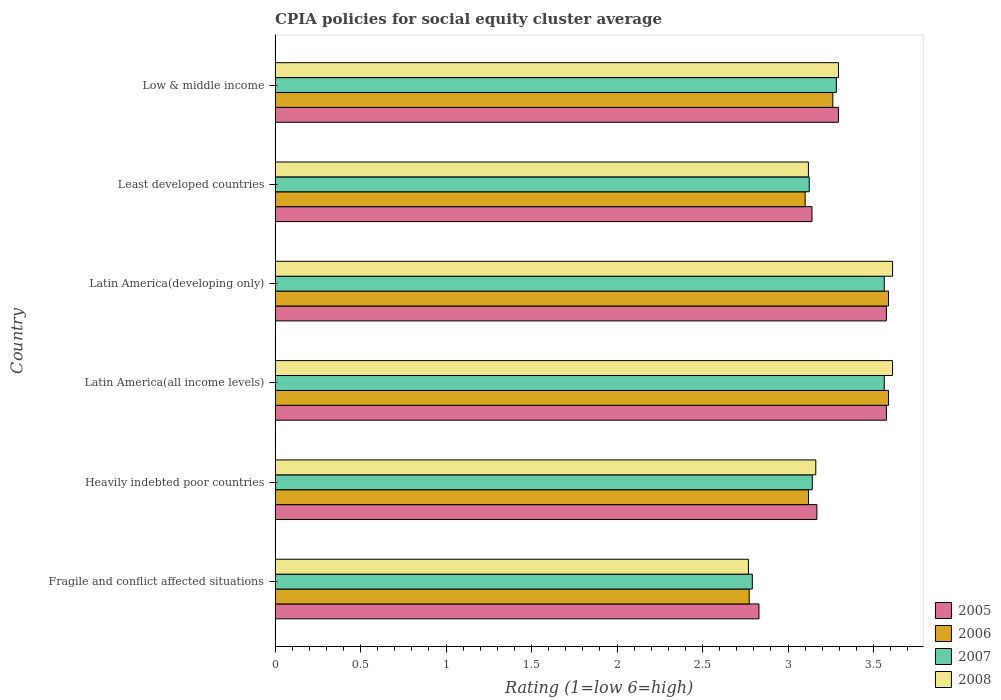How many groups of bars are there?
Your answer should be compact. 6. How many bars are there on the 4th tick from the top?
Your response must be concise. 4. How many bars are there on the 6th tick from the bottom?
Keep it short and to the point. 4. What is the label of the 4th group of bars from the top?
Provide a short and direct response. Latin America(all income levels). In how many cases, is the number of bars for a given country not equal to the number of legend labels?
Offer a terse response. 0. What is the CPIA rating in 2006 in Latin America(all income levels)?
Offer a terse response. 3.59. Across all countries, what is the maximum CPIA rating in 2008?
Provide a succinct answer. 3.61. Across all countries, what is the minimum CPIA rating in 2008?
Offer a very short reply. 2.77. In which country was the CPIA rating in 2005 maximum?
Give a very brief answer. Latin America(all income levels). In which country was the CPIA rating in 2007 minimum?
Make the answer very short. Fragile and conflict affected situations. What is the total CPIA rating in 2005 in the graph?
Provide a succinct answer. 19.58. What is the difference between the CPIA rating in 2006 in Latin America(developing only) and that in Least developed countries?
Provide a succinct answer. 0.49. What is the difference between the CPIA rating in 2007 in Latin America(developing only) and the CPIA rating in 2006 in Least developed countries?
Give a very brief answer. 0.46. What is the average CPIA rating in 2006 per country?
Your answer should be very brief. 3.24. What is the difference between the CPIA rating in 2007 and CPIA rating in 2008 in Fragile and conflict affected situations?
Provide a short and direct response. 0.02. In how many countries, is the CPIA rating in 2007 greater than 3.3 ?
Offer a very short reply. 2. What is the ratio of the CPIA rating in 2006 in Latin America(developing only) to that in Low & middle income?
Keep it short and to the point. 1.1. Is the difference between the CPIA rating in 2007 in Fragile and conflict affected situations and Latin America(all income levels) greater than the difference between the CPIA rating in 2008 in Fragile and conflict affected situations and Latin America(all income levels)?
Your answer should be very brief. Yes. What is the difference between the highest and the second highest CPIA rating in 2005?
Your answer should be very brief. 0. What is the difference between the highest and the lowest CPIA rating in 2005?
Offer a very short reply. 0.75. In how many countries, is the CPIA rating in 2007 greater than the average CPIA rating in 2007 taken over all countries?
Offer a terse response. 3. What does the 2nd bar from the top in Least developed countries represents?
Ensure brevity in your answer.  2007. Is it the case that in every country, the sum of the CPIA rating in 2007 and CPIA rating in 2006 is greater than the CPIA rating in 2008?
Your response must be concise. Yes. How many bars are there?
Ensure brevity in your answer.  24. How many countries are there in the graph?
Keep it short and to the point. 6. What is the difference between two consecutive major ticks on the X-axis?
Ensure brevity in your answer.  0.5. Does the graph contain any zero values?
Provide a succinct answer. No. Where does the legend appear in the graph?
Offer a very short reply. Bottom right. How many legend labels are there?
Offer a very short reply. 4. What is the title of the graph?
Offer a very short reply. CPIA policies for social equity cluster average. What is the label or title of the X-axis?
Offer a very short reply. Rating (1=low 6=high). What is the Rating (1=low 6=high) of 2005 in Fragile and conflict affected situations?
Your response must be concise. 2.83. What is the Rating (1=low 6=high) of 2006 in Fragile and conflict affected situations?
Ensure brevity in your answer.  2.77. What is the Rating (1=low 6=high) in 2007 in Fragile and conflict affected situations?
Ensure brevity in your answer.  2.79. What is the Rating (1=low 6=high) of 2008 in Fragile and conflict affected situations?
Your answer should be compact. 2.77. What is the Rating (1=low 6=high) in 2005 in Heavily indebted poor countries?
Your answer should be compact. 3.17. What is the Rating (1=low 6=high) in 2006 in Heavily indebted poor countries?
Provide a short and direct response. 3.12. What is the Rating (1=low 6=high) in 2007 in Heavily indebted poor countries?
Offer a terse response. 3.14. What is the Rating (1=low 6=high) of 2008 in Heavily indebted poor countries?
Ensure brevity in your answer.  3.16. What is the Rating (1=low 6=high) of 2005 in Latin America(all income levels)?
Ensure brevity in your answer.  3.58. What is the Rating (1=low 6=high) in 2006 in Latin America(all income levels)?
Ensure brevity in your answer.  3.59. What is the Rating (1=low 6=high) in 2007 in Latin America(all income levels)?
Your answer should be compact. 3.56. What is the Rating (1=low 6=high) in 2008 in Latin America(all income levels)?
Offer a very short reply. 3.61. What is the Rating (1=low 6=high) in 2005 in Latin America(developing only)?
Your answer should be compact. 3.58. What is the Rating (1=low 6=high) of 2006 in Latin America(developing only)?
Keep it short and to the point. 3.59. What is the Rating (1=low 6=high) in 2007 in Latin America(developing only)?
Offer a terse response. 3.56. What is the Rating (1=low 6=high) of 2008 in Latin America(developing only)?
Your answer should be very brief. 3.61. What is the Rating (1=low 6=high) of 2005 in Least developed countries?
Offer a terse response. 3.14. What is the Rating (1=low 6=high) in 2006 in Least developed countries?
Provide a succinct answer. 3.1. What is the Rating (1=low 6=high) in 2007 in Least developed countries?
Provide a short and direct response. 3.12. What is the Rating (1=low 6=high) in 2008 in Least developed countries?
Offer a terse response. 3.12. What is the Rating (1=low 6=high) in 2005 in Low & middle income?
Give a very brief answer. 3.29. What is the Rating (1=low 6=high) of 2006 in Low & middle income?
Your response must be concise. 3.26. What is the Rating (1=low 6=high) in 2007 in Low & middle income?
Your response must be concise. 3.28. What is the Rating (1=low 6=high) in 2008 in Low & middle income?
Keep it short and to the point. 3.29. Across all countries, what is the maximum Rating (1=low 6=high) of 2005?
Your response must be concise. 3.58. Across all countries, what is the maximum Rating (1=low 6=high) of 2006?
Your answer should be compact. 3.59. Across all countries, what is the maximum Rating (1=low 6=high) in 2007?
Provide a short and direct response. 3.56. Across all countries, what is the maximum Rating (1=low 6=high) of 2008?
Provide a short and direct response. 3.61. Across all countries, what is the minimum Rating (1=low 6=high) of 2005?
Offer a very short reply. 2.83. Across all countries, what is the minimum Rating (1=low 6=high) in 2006?
Your answer should be very brief. 2.77. Across all countries, what is the minimum Rating (1=low 6=high) of 2007?
Ensure brevity in your answer.  2.79. Across all countries, what is the minimum Rating (1=low 6=high) in 2008?
Provide a succinct answer. 2.77. What is the total Rating (1=low 6=high) of 2005 in the graph?
Ensure brevity in your answer.  19.58. What is the total Rating (1=low 6=high) of 2006 in the graph?
Give a very brief answer. 19.43. What is the total Rating (1=low 6=high) of 2007 in the graph?
Your answer should be very brief. 19.46. What is the total Rating (1=low 6=high) of 2008 in the graph?
Provide a succinct answer. 19.57. What is the difference between the Rating (1=low 6=high) in 2005 in Fragile and conflict affected situations and that in Heavily indebted poor countries?
Give a very brief answer. -0.34. What is the difference between the Rating (1=low 6=high) of 2006 in Fragile and conflict affected situations and that in Heavily indebted poor countries?
Ensure brevity in your answer.  -0.35. What is the difference between the Rating (1=low 6=high) in 2007 in Fragile and conflict affected situations and that in Heavily indebted poor countries?
Your answer should be compact. -0.35. What is the difference between the Rating (1=low 6=high) in 2008 in Fragile and conflict affected situations and that in Heavily indebted poor countries?
Your response must be concise. -0.39. What is the difference between the Rating (1=low 6=high) in 2005 in Fragile and conflict affected situations and that in Latin America(all income levels)?
Offer a very short reply. -0.74. What is the difference between the Rating (1=low 6=high) in 2006 in Fragile and conflict affected situations and that in Latin America(all income levels)?
Make the answer very short. -0.81. What is the difference between the Rating (1=low 6=high) of 2007 in Fragile and conflict affected situations and that in Latin America(all income levels)?
Keep it short and to the point. -0.77. What is the difference between the Rating (1=low 6=high) in 2008 in Fragile and conflict affected situations and that in Latin America(all income levels)?
Offer a terse response. -0.84. What is the difference between the Rating (1=low 6=high) of 2005 in Fragile and conflict affected situations and that in Latin America(developing only)?
Keep it short and to the point. -0.74. What is the difference between the Rating (1=low 6=high) in 2006 in Fragile and conflict affected situations and that in Latin America(developing only)?
Give a very brief answer. -0.81. What is the difference between the Rating (1=low 6=high) in 2007 in Fragile and conflict affected situations and that in Latin America(developing only)?
Offer a terse response. -0.77. What is the difference between the Rating (1=low 6=high) in 2008 in Fragile and conflict affected situations and that in Latin America(developing only)?
Your response must be concise. -0.84. What is the difference between the Rating (1=low 6=high) of 2005 in Fragile and conflict affected situations and that in Least developed countries?
Your response must be concise. -0.31. What is the difference between the Rating (1=low 6=high) in 2006 in Fragile and conflict affected situations and that in Least developed countries?
Offer a very short reply. -0.33. What is the difference between the Rating (1=low 6=high) of 2007 in Fragile and conflict affected situations and that in Least developed countries?
Ensure brevity in your answer.  -0.33. What is the difference between the Rating (1=low 6=high) of 2008 in Fragile and conflict affected situations and that in Least developed countries?
Ensure brevity in your answer.  -0.35. What is the difference between the Rating (1=low 6=high) of 2005 in Fragile and conflict affected situations and that in Low & middle income?
Ensure brevity in your answer.  -0.46. What is the difference between the Rating (1=low 6=high) in 2006 in Fragile and conflict affected situations and that in Low & middle income?
Keep it short and to the point. -0.49. What is the difference between the Rating (1=low 6=high) of 2007 in Fragile and conflict affected situations and that in Low & middle income?
Your answer should be very brief. -0.49. What is the difference between the Rating (1=low 6=high) in 2008 in Fragile and conflict affected situations and that in Low & middle income?
Make the answer very short. -0.53. What is the difference between the Rating (1=low 6=high) in 2005 in Heavily indebted poor countries and that in Latin America(all income levels)?
Keep it short and to the point. -0.41. What is the difference between the Rating (1=low 6=high) in 2006 in Heavily indebted poor countries and that in Latin America(all income levels)?
Provide a succinct answer. -0.47. What is the difference between the Rating (1=low 6=high) of 2007 in Heavily indebted poor countries and that in Latin America(all income levels)?
Offer a terse response. -0.42. What is the difference between the Rating (1=low 6=high) in 2008 in Heavily indebted poor countries and that in Latin America(all income levels)?
Offer a very short reply. -0.45. What is the difference between the Rating (1=low 6=high) in 2005 in Heavily indebted poor countries and that in Latin America(developing only)?
Your response must be concise. -0.41. What is the difference between the Rating (1=low 6=high) in 2006 in Heavily indebted poor countries and that in Latin America(developing only)?
Make the answer very short. -0.47. What is the difference between the Rating (1=low 6=high) in 2007 in Heavily indebted poor countries and that in Latin America(developing only)?
Offer a terse response. -0.42. What is the difference between the Rating (1=low 6=high) of 2008 in Heavily indebted poor countries and that in Latin America(developing only)?
Provide a short and direct response. -0.45. What is the difference between the Rating (1=low 6=high) of 2005 in Heavily indebted poor countries and that in Least developed countries?
Keep it short and to the point. 0.03. What is the difference between the Rating (1=low 6=high) in 2006 in Heavily indebted poor countries and that in Least developed countries?
Keep it short and to the point. 0.02. What is the difference between the Rating (1=low 6=high) of 2007 in Heavily indebted poor countries and that in Least developed countries?
Give a very brief answer. 0.02. What is the difference between the Rating (1=low 6=high) in 2008 in Heavily indebted poor countries and that in Least developed countries?
Make the answer very short. 0.04. What is the difference between the Rating (1=low 6=high) in 2005 in Heavily indebted poor countries and that in Low & middle income?
Keep it short and to the point. -0.13. What is the difference between the Rating (1=low 6=high) of 2006 in Heavily indebted poor countries and that in Low & middle income?
Offer a terse response. -0.14. What is the difference between the Rating (1=low 6=high) in 2007 in Heavily indebted poor countries and that in Low & middle income?
Your response must be concise. -0.14. What is the difference between the Rating (1=low 6=high) in 2008 in Heavily indebted poor countries and that in Low & middle income?
Your answer should be compact. -0.13. What is the difference between the Rating (1=low 6=high) of 2005 in Latin America(all income levels) and that in Latin America(developing only)?
Offer a terse response. 0. What is the difference between the Rating (1=low 6=high) of 2007 in Latin America(all income levels) and that in Latin America(developing only)?
Keep it short and to the point. 0. What is the difference between the Rating (1=low 6=high) in 2005 in Latin America(all income levels) and that in Least developed countries?
Your answer should be compact. 0.43. What is the difference between the Rating (1=low 6=high) of 2006 in Latin America(all income levels) and that in Least developed countries?
Your answer should be compact. 0.49. What is the difference between the Rating (1=low 6=high) of 2007 in Latin America(all income levels) and that in Least developed countries?
Give a very brief answer. 0.44. What is the difference between the Rating (1=low 6=high) of 2008 in Latin America(all income levels) and that in Least developed countries?
Provide a succinct answer. 0.49. What is the difference between the Rating (1=low 6=high) of 2005 in Latin America(all income levels) and that in Low & middle income?
Your answer should be compact. 0.28. What is the difference between the Rating (1=low 6=high) of 2006 in Latin America(all income levels) and that in Low & middle income?
Offer a very short reply. 0.33. What is the difference between the Rating (1=low 6=high) in 2007 in Latin America(all income levels) and that in Low & middle income?
Your response must be concise. 0.28. What is the difference between the Rating (1=low 6=high) in 2008 in Latin America(all income levels) and that in Low & middle income?
Ensure brevity in your answer.  0.32. What is the difference between the Rating (1=low 6=high) of 2005 in Latin America(developing only) and that in Least developed countries?
Offer a terse response. 0.43. What is the difference between the Rating (1=low 6=high) in 2006 in Latin America(developing only) and that in Least developed countries?
Your answer should be very brief. 0.49. What is the difference between the Rating (1=low 6=high) in 2007 in Latin America(developing only) and that in Least developed countries?
Make the answer very short. 0.44. What is the difference between the Rating (1=low 6=high) in 2008 in Latin America(developing only) and that in Least developed countries?
Your response must be concise. 0.49. What is the difference between the Rating (1=low 6=high) of 2005 in Latin America(developing only) and that in Low & middle income?
Offer a terse response. 0.28. What is the difference between the Rating (1=low 6=high) in 2006 in Latin America(developing only) and that in Low & middle income?
Provide a succinct answer. 0.33. What is the difference between the Rating (1=low 6=high) in 2007 in Latin America(developing only) and that in Low & middle income?
Provide a succinct answer. 0.28. What is the difference between the Rating (1=low 6=high) in 2008 in Latin America(developing only) and that in Low & middle income?
Provide a succinct answer. 0.32. What is the difference between the Rating (1=low 6=high) of 2005 in Least developed countries and that in Low & middle income?
Your answer should be compact. -0.15. What is the difference between the Rating (1=low 6=high) in 2006 in Least developed countries and that in Low & middle income?
Offer a very short reply. -0.16. What is the difference between the Rating (1=low 6=high) of 2007 in Least developed countries and that in Low & middle income?
Keep it short and to the point. -0.16. What is the difference between the Rating (1=low 6=high) of 2008 in Least developed countries and that in Low & middle income?
Offer a terse response. -0.18. What is the difference between the Rating (1=low 6=high) in 2005 in Fragile and conflict affected situations and the Rating (1=low 6=high) in 2006 in Heavily indebted poor countries?
Ensure brevity in your answer.  -0.29. What is the difference between the Rating (1=low 6=high) of 2005 in Fragile and conflict affected situations and the Rating (1=low 6=high) of 2007 in Heavily indebted poor countries?
Offer a terse response. -0.31. What is the difference between the Rating (1=low 6=high) of 2005 in Fragile and conflict affected situations and the Rating (1=low 6=high) of 2008 in Heavily indebted poor countries?
Your answer should be very brief. -0.33. What is the difference between the Rating (1=low 6=high) in 2006 in Fragile and conflict affected situations and the Rating (1=low 6=high) in 2007 in Heavily indebted poor countries?
Offer a very short reply. -0.37. What is the difference between the Rating (1=low 6=high) in 2006 in Fragile and conflict affected situations and the Rating (1=low 6=high) in 2008 in Heavily indebted poor countries?
Your answer should be compact. -0.39. What is the difference between the Rating (1=low 6=high) in 2007 in Fragile and conflict affected situations and the Rating (1=low 6=high) in 2008 in Heavily indebted poor countries?
Offer a terse response. -0.37. What is the difference between the Rating (1=low 6=high) in 2005 in Fragile and conflict affected situations and the Rating (1=low 6=high) in 2006 in Latin America(all income levels)?
Make the answer very short. -0.76. What is the difference between the Rating (1=low 6=high) in 2005 in Fragile and conflict affected situations and the Rating (1=low 6=high) in 2007 in Latin America(all income levels)?
Keep it short and to the point. -0.73. What is the difference between the Rating (1=low 6=high) of 2005 in Fragile and conflict affected situations and the Rating (1=low 6=high) of 2008 in Latin America(all income levels)?
Offer a terse response. -0.78. What is the difference between the Rating (1=low 6=high) of 2006 in Fragile and conflict affected situations and the Rating (1=low 6=high) of 2007 in Latin America(all income levels)?
Provide a short and direct response. -0.79. What is the difference between the Rating (1=low 6=high) in 2006 in Fragile and conflict affected situations and the Rating (1=low 6=high) in 2008 in Latin America(all income levels)?
Make the answer very short. -0.84. What is the difference between the Rating (1=low 6=high) of 2007 in Fragile and conflict affected situations and the Rating (1=low 6=high) of 2008 in Latin America(all income levels)?
Provide a succinct answer. -0.82. What is the difference between the Rating (1=low 6=high) in 2005 in Fragile and conflict affected situations and the Rating (1=low 6=high) in 2006 in Latin America(developing only)?
Make the answer very short. -0.76. What is the difference between the Rating (1=low 6=high) in 2005 in Fragile and conflict affected situations and the Rating (1=low 6=high) in 2007 in Latin America(developing only)?
Your answer should be very brief. -0.73. What is the difference between the Rating (1=low 6=high) of 2005 in Fragile and conflict affected situations and the Rating (1=low 6=high) of 2008 in Latin America(developing only)?
Your answer should be very brief. -0.78. What is the difference between the Rating (1=low 6=high) in 2006 in Fragile and conflict affected situations and the Rating (1=low 6=high) in 2007 in Latin America(developing only)?
Provide a succinct answer. -0.79. What is the difference between the Rating (1=low 6=high) in 2006 in Fragile and conflict affected situations and the Rating (1=low 6=high) in 2008 in Latin America(developing only)?
Make the answer very short. -0.84. What is the difference between the Rating (1=low 6=high) of 2007 in Fragile and conflict affected situations and the Rating (1=low 6=high) of 2008 in Latin America(developing only)?
Provide a short and direct response. -0.82. What is the difference between the Rating (1=low 6=high) in 2005 in Fragile and conflict affected situations and the Rating (1=low 6=high) in 2006 in Least developed countries?
Offer a very short reply. -0.27. What is the difference between the Rating (1=low 6=high) in 2005 in Fragile and conflict affected situations and the Rating (1=low 6=high) in 2007 in Least developed countries?
Make the answer very short. -0.29. What is the difference between the Rating (1=low 6=high) of 2005 in Fragile and conflict affected situations and the Rating (1=low 6=high) of 2008 in Least developed countries?
Your answer should be very brief. -0.29. What is the difference between the Rating (1=low 6=high) of 2006 in Fragile and conflict affected situations and the Rating (1=low 6=high) of 2007 in Least developed countries?
Offer a very short reply. -0.35. What is the difference between the Rating (1=low 6=high) in 2006 in Fragile and conflict affected situations and the Rating (1=low 6=high) in 2008 in Least developed countries?
Offer a terse response. -0.35. What is the difference between the Rating (1=low 6=high) in 2007 in Fragile and conflict affected situations and the Rating (1=low 6=high) in 2008 in Least developed countries?
Your answer should be very brief. -0.33. What is the difference between the Rating (1=low 6=high) in 2005 in Fragile and conflict affected situations and the Rating (1=low 6=high) in 2006 in Low & middle income?
Ensure brevity in your answer.  -0.43. What is the difference between the Rating (1=low 6=high) in 2005 in Fragile and conflict affected situations and the Rating (1=low 6=high) in 2007 in Low & middle income?
Your answer should be very brief. -0.45. What is the difference between the Rating (1=low 6=high) in 2005 in Fragile and conflict affected situations and the Rating (1=low 6=high) in 2008 in Low & middle income?
Provide a short and direct response. -0.46. What is the difference between the Rating (1=low 6=high) in 2006 in Fragile and conflict affected situations and the Rating (1=low 6=high) in 2007 in Low & middle income?
Give a very brief answer. -0.51. What is the difference between the Rating (1=low 6=high) of 2006 in Fragile and conflict affected situations and the Rating (1=low 6=high) of 2008 in Low & middle income?
Your response must be concise. -0.52. What is the difference between the Rating (1=low 6=high) of 2007 in Fragile and conflict affected situations and the Rating (1=low 6=high) of 2008 in Low & middle income?
Ensure brevity in your answer.  -0.5. What is the difference between the Rating (1=low 6=high) in 2005 in Heavily indebted poor countries and the Rating (1=low 6=high) in 2006 in Latin America(all income levels)?
Your answer should be compact. -0.42. What is the difference between the Rating (1=low 6=high) in 2005 in Heavily indebted poor countries and the Rating (1=low 6=high) in 2007 in Latin America(all income levels)?
Make the answer very short. -0.39. What is the difference between the Rating (1=low 6=high) in 2005 in Heavily indebted poor countries and the Rating (1=low 6=high) in 2008 in Latin America(all income levels)?
Provide a succinct answer. -0.44. What is the difference between the Rating (1=low 6=high) in 2006 in Heavily indebted poor countries and the Rating (1=low 6=high) in 2007 in Latin America(all income levels)?
Offer a terse response. -0.44. What is the difference between the Rating (1=low 6=high) of 2006 in Heavily indebted poor countries and the Rating (1=low 6=high) of 2008 in Latin America(all income levels)?
Your response must be concise. -0.49. What is the difference between the Rating (1=low 6=high) of 2007 in Heavily indebted poor countries and the Rating (1=low 6=high) of 2008 in Latin America(all income levels)?
Your response must be concise. -0.47. What is the difference between the Rating (1=low 6=high) of 2005 in Heavily indebted poor countries and the Rating (1=low 6=high) of 2006 in Latin America(developing only)?
Your response must be concise. -0.42. What is the difference between the Rating (1=low 6=high) in 2005 in Heavily indebted poor countries and the Rating (1=low 6=high) in 2007 in Latin America(developing only)?
Your answer should be compact. -0.39. What is the difference between the Rating (1=low 6=high) in 2005 in Heavily indebted poor countries and the Rating (1=low 6=high) in 2008 in Latin America(developing only)?
Make the answer very short. -0.44. What is the difference between the Rating (1=low 6=high) in 2006 in Heavily indebted poor countries and the Rating (1=low 6=high) in 2007 in Latin America(developing only)?
Offer a very short reply. -0.44. What is the difference between the Rating (1=low 6=high) in 2006 in Heavily indebted poor countries and the Rating (1=low 6=high) in 2008 in Latin America(developing only)?
Offer a very short reply. -0.49. What is the difference between the Rating (1=low 6=high) in 2007 in Heavily indebted poor countries and the Rating (1=low 6=high) in 2008 in Latin America(developing only)?
Ensure brevity in your answer.  -0.47. What is the difference between the Rating (1=low 6=high) in 2005 in Heavily indebted poor countries and the Rating (1=low 6=high) in 2006 in Least developed countries?
Your response must be concise. 0.07. What is the difference between the Rating (1=low 6=high) of 2005 in Heavily indebted poor countries and the Rating (1=low 6=high) of 2007 in Least developed countries?
Make the answer very short. 0.04. What is the difference between the Rating (1=low 6=high) in 2005 in Heavily indebted poor countries and the Rating (1=low 6=high) in 2008 in Least developed countries?
Offer a very short reply. 0.05. What is the difference between the Rating (1=low 6=high) in 2006 in Heavily indebted poor countries and the Rating (1=low 6=high) in 2007 in Least developed countries?
Give a very brief answer. -0. What is the difference between the Rating (1=low 6=high) in 2006 in Heavily indebted poor countries and the Rating (1=low 6=high) in 2008 in Least developed countries?
Your answer should be very brief. 0. What is the difference between the Rating (1=low 6=high) of 2007 in Heavily indebted poor countries and the Rating (1=low 6=high) of 2008 in Least developed countries?
Give a very brief answer. 0.02. What is the difference between the Rating (1=low 6=high) in 2005 in Heavily indebted poor countries and the Rating (1=low 6=high) in 2006 in Low & middle income?
Ensure brevity in your answer.  -0.09. What is the difference between the Rating (1=low 6=high) of 2005 in Heavily indebted poor countries and the Rating (1=low 6=high) of 2007 in Low & middle income?
Offer a very short reply. -0.11. What is the difference between the Rating (1=low 6=high) of 2005 in Heavily indebted poor countries and the Rating (1=low 6=high) of 2008 in Low & middle income?
Provide a succinct answer. -0.13. What is the difference between the Rating (1=low 6=high) of 2006 in Heavily indebted poor countries and the Rating (1=low 6=high) of 2007 in Low & middle income?
Your answer should be compact. -0.16. What is the difference between the Rating (1=low 6=high) in 2006 in Heavily indebted poor countries and the Rating (1=low 6=high) in 2008 in Low & middle income?
Give a very brief answer. -0.18. What is the difference between the Rating (1=low 6=high) in 2007 in Heavily indebted poor countries and the Rating (1=low 6=high) in 2008 in Low & middle income?
Provide a short and direct response. -0.15. What is the difference between the Rating (1=low 6=high) of 2005 in Latin America(all income levels) and the Rating (1=low 6=high) of 2006 in Latin America(developing only)?
Make the answer very short. -0.01. What is the difference between the Rating (1=low 6=high) in 2005 in Latin America(all income levels) and the Rating (1=low 6=high) in 2007 in Latin America(developing only)?
Your answer should be compact. 0.01. What is the difference between the Rating (1=low 6=high) of 2005 in Latin America(all income levels) and the Rating (1=low 6=high) of 2008 in Latin America(developing only)?
Your answer should be compact. -0.04. What is the difference between the Rating (1=low 6=high) of 2006 in Latin America(all income levels) and the Rating (1=low 6=high) of 2007 in Latin America(developing only)?
Provide a short and direct response. 0.03. What is the difference between the Rating (1=low 6=high) of 2006 in Latin America(all income levels) and the Rating (1=low 6=high) of 2008 in Latin America(developing only)?
Offer a terse response. -0.02. What is the difference between the Rating (1=low 6=high) in 2007 in Latin America(all income levels) and the Rating (1=low 6=high) in 2008 in Latin America(developing only)?
Your response must be concise. -0.05. What is the difference between the Rating (1=low 6=high) in 2005 in Latin America(all income levels) and the Rating (1=low 6=high) in 2006 in Least developed countries?
Your answer should be compact. 0.47. What is the difference between the Rating (1=low 6=high) of 2005 in Latin America(all income levels) and the Rating (1=low 6=high) of 2007 in Least developed countries?
Ensure brevity in your answer.  0.45. What is the difference between the Rating (1=low 6=high) of 2005 in Latin America(all income levels) and the Rating (1=low 6=high) of 2008 in Least developed countries?
Provide a succinct answer. 0.46. What is the difference between the Rating (1=low 6=high) in 2006 in Latin America(all income levels) and the Rating (1=low 6=high) in 2007 in Least developed countries?
Ensure brevity in your answer.  0.46. What is the difference between the Rating (1=low 6=high) in 2006 in Latin America(all income levels) and the Rating (1=low 6=high) in 2008 in Least developed countries?
Offer a terse response. 0.47. What is the difference between the Rating (1=low 6=high) in 2007 in Latin America(all income levels) and the Rating (1=low 6=high) in 2008 in Least developed countries?
Offer a very short reply. 0.44. What is the difference between the Rating (1=low 6=high) of 2005 in Latin America(all income levels) and the Rating (1=low 6=high) of 2006 in Low & middle income?
Provide a succinct answer. 0.31. What is the difference between the Rating (1=low 6=high) of 2005 in Latin America(all income levels) and the Rating (1=low 6=high) of 2007 in Low & middle income?
Ensure brevity in your answer.  0.29. What is the difference between the Rating (1=low 6=high) in 2005 in Latin America(all income levels) and the Rating (1=low 6=high) in 2008 in Low & middle income?
Provide a short and direct response. 0.28. What is the difference between the Rating (1=low 6=high) of 2006 in Latin America(all income levels) and the Rating (1=low 6=high) of 2007 in Low & middle income?
Keep it short and to the point. 0.31. What is the difference between the Rating (1=low 6=high) in 2006 in Latin America(all income levels) and the Rating (1=low 6=high) in 2008 in Low & middle income?
Your response must be concise. 0.29. What is the difference between the Rating (1=low 6=high) in 2007 in Latin America(all income levels) and the Rating (1=low 6=high) in 2008 in Low & middle income?
Your answer should be compact. 0.27. What is the difference between the Rating (1=low 6=high) in 2005 in Latin America(developing only) and the Rating (1=low 6=high) in 2006 in Least developed countries?
Keep it short and to the point. 0.47. What is the difference between the Rating (1=low 6=high) of 2005 in Latin America(developing only) and the Rating (1=low 6=high) of 2007 in Least developed countries?
Offer a very short reply. 0.45. What is the difference between the Rating (1=low 6=high) in 2005 in Latin America(developing only) and the Rating (1=low 6=high) in 2008 in Least developed countries?
Your answer should be very brief. 0.46. What is the difference between the Rating (1=low 6=high) of 2006 in Latin America(developing only) and the Rating (1=low 6=high) of 2007 in Least developed countries?
Offer a terse response. 0.46. What is the difference between the Rating (1=low 6=high) of 2006 in Latin America(developing only) and the Rating (1=low 6=high) of 2008 in Least developed countries?
Provide a succinct answer. 0.47. What is the difference between the Rating (1=low 6=high) in 2007 in Latin America(developing only) and the Rating (1=low 6=high) in 2008 in Least developed countries?
Ensure brevity in your answer.  0.44. What is the difference between the Rating (1=low 6=high) of 2005 in Latin America(developing only) and the Rating (1=low 6=high) of 2006 in Low & middle income?
Your response must be concise. 0.31. What is the difference between the Rating (1=low 6=high) in 2005 in Latin America(developing only) and the Rating (1=low 6=high) in 2007 in Low & middle income?
Your answer should be very brief. 0.29. What is the difference between the Rating (1=low 6=high) of 2005 in Latin America(developing only) and the Rating (1=low 6=high) of 2008 in Low & middle income?
Your answer should be very brief. 0.28. What is the difference between the Rating (1=low 6=high) in 2006 in Latin America(developing only) and the Rating (1=low 6=high) in 2007 in Low & middle income?
Give a very brief answer. 0.31. What is the difference between the Rating (1=low 6=high) of 2006 in Latin America(developing only) and the Rating (1=low 6=high) of 2008 in Low & middle income?
Give a very brief answer. 0.29. What is the difference between the Rating (1=low 6=high) of 2007 in Latin America(developing only) and the Rating (1=low 6=high) of 2008 in Low & middle income?
Make the answer very short. 0.27. What is the difference between the Rating (1=low 6=high) in 2005 in Least developed countries and the Rating (1=low 6=high) in 2006 in Low & middle income?
Make the answer very short. -0.12. What is the difference between the Rating (1=low 6=high) in 2005 in Least developed countries and the Rating (1=low 6=high) in 2007 in Low & middle income?
Offer a very short reply. -0.14. What is the difference between the Rating (1=low 6=high) in 2005 in Least developed countries and the Rating (1=low 6=high) in 2008 in Low & middle income?
Provide a short and direct response. -0.15. What is the difference between the Rating (1=low 6=high) of 2006 in Least developed countries and the Rating (1=low 6=high) of 2007 in Low & middle income?
Your answer should be very brief. -0.18. What is the difference between the Rating (1=low 6=high) in 2006 in Least developed countries and the Rating (1=low 6=high) in 2008 in Low & middle income?
Your answer should be very brief. -0.19. What is the difference between the Rating (1=low 6=high) in 2007 in Least developed countries and the Rating (1=low 6=high) in 2008 in Low & middle income?
Offer a very short reply. -0.17. What is the average Rating (1=low 6=high) in 2005 per country?
Provide a short and direct response. 3.26. What is the average Rating (1=low 6=high) in 2006 per country?
Give a very brief answer. 3.24. What is the average Rating (1=low 6=high) of 2007 per country?
Your answer should be very brief. 3.24. What is the average Rating (1=low 6=high) in 2008 per country?
Your answer should be very brief. 3.26. What is the difference between the Rating (1=low 6=high) of 2005 and Rating (1=low 6=high) of 2006 in Fragile and conflict affected situations?
Your answer should be very brief. 0.06. What is the difference between the Rating (1=low 6=high) of 2005 and Rating (1=low 6=high) of 2007 in Fragile and conflict affected situations?
Offer a very short reply. 0.04. What is the difference between the Rating (1=low 6=high) of 2005 and Rating (1=low 6=high) of 2008 in Fragile and conflict affected situations?
Your answer should be compact. 0.06. What is the difference between the Rating (1=low 6=high) in 2006 and Rating (1=low 6=high) in 2007 in Fragile and conflict affected situations?
Provide a succinct answer. -0.02. What is the difference between the Rating (1=low 6=high) in 2006 and Rating (1=low 6=high) in 2008 in Fragile and conflict affected situations?
Provide a succinct answer. 0. What is the difference between the Rating (1=low 6=high) of 2007 and Rating (1=low 6=high) of 2008 in Fragile and conflict affected situations?
Make the answer very short. 0.02. What is the difference between the Rating (1=low 6=high) in 2005 and Rating (1=low 6=high) in 2006 in Heavily indebted poor countries?
Give a very brief answer. 0.05. What is the difference between the Rating (1=low 6=high) in 2005 and Rating (1=low 6=high) in 2007 in Heavily indebted poor countries?
Keep it short and to the point. 0.03. What is the difference between the Rating (1=low 6=high) of 2005 and Rating (1=low 6=high) of 2008 in Heavily indebted poor countries?
Offer a very short reply. 0.01. What is the difference between the Rating (1=low 6=high) of 2006 and Rating (1=low 6=high) of 2007 in Heavily indebted poor countries?
Provide a succinct answer. -0.02. What is the difference between the Rating (1=low 6=high) of 2006 and Rating (1=low 6=high) of 2008 in Heavily indebted poor countries?
Offer a very short reply. -0.04. What is the difference between the Rating (1=low 6=high) in 2007 and Rating (1=low 6=high) in 2008 in Heavily indebted poor countries?
Provide a short and direct response. -0.02. What is the difference between the Rating (1=low 6=high) in 2005 and Rating (1=low 6=high) in 2006 in Latin America(all income levels)?
Your answer should be very brief. -0.01. What is the difference between the Rating (1=low 6=high) in 2005 and Rating (1=low 6=high) in 2007 in Latin America(all income levels)?
Make the answer very short. 0.01. What is the difference between the Rating (1=low 6=high) in 2005 and Rating (1=low 6=high) in 2008 in Latin America(all income levels)?
Give a very brief answer. -0.04. What is the difference between the Rating (1=low 6=high) in 2006 and Rating (1=low 6=high) in 2007 in Latin America(all income levels)?
Your answer should be very brief. 0.03. What is the difference between the Rating (1=low 6=high) in 2006 and Rating (1=low 6=high) in 2008 in Latin America(all income levels)?
Make the answer very short. -0.02. What is the difference between the Rating (1=low 6=high) of 2007 and Rating (1=low 6=high) of 2008 in Latin America(all income levels)?
Make the answer very short. -0.05. What is the difference between the Rating (1=low 6=high) in 2005 and Rating (1=low 6=high) in 2006 in Latin America(developing only)?
Ensure brevity in your answer.  -0.01. What is the difference between the Rating (1=low 6=high) of 2005 and Rating (1=low 6=high) of 2007 in Latin America(developing only)?
Give a very brief answer. 0.01. What is the difference between the Rating (1=low 6=high) in 2005 and Rating (1=low 6=high) in 2008 in Latin America(developing only)?
Ensure brevity in your answer.  -0.04. What is the difference between the Rating (1=low 6=high) of 2006 and Rating (1=low 6=high) of 2007 in Latin America(developing only)?
Offer a very short reply. 0.03. What is the difference between the Rating (1=low 6=high) in 2006 and Rating (1=low 6=high) in 2008 in Latin America(developing only)?
Offer a terse response. -0.02. What is the difference between the Rating (1=low 6=high) in 2007 and Rating (1=low 6=high) in 2008 in Latin America(developing only)?
Give a very brief answer. -0.05. What is the difference between the Rating (1=low 6=high) in 2005 and Rating (1=low 6=high) in 2007 in Least developed countries?
Provide a short and direct response. 0.02. What is the difference between the Rating (1=low 6=high) of 2005 and Rating (1=low 6=high) of 2008 in Least developed countries?
Keep it short and to the point. 0.02. What is the difference between the Rating (1=low 6=high) in 2006 and Rating (1=low 6=high) in 2007 in Least developed countries?
Your answer should be very brief. -0.02. What is the difference between the Rating (1=low 6=high) in 2006 and Rating (1=low 6=high) in 2008 in Least developed countries?
Your answer should be very brief. -0.02. What is the difference between the Rating (1=low 6=high) of 2007 and Rating (1=low 6=high) of 2008 in Least developed countries?
Offer a terse response. 0. What is the difference between the Rating (1=low 6=high) of 2005 and Rating (1=low 6=high) of 2006 in Low & middle income?
Your answer should be very brief. 0.03. What is the difference between the Rating (1=low 6=high) of 2005 and Rating (1=low 6=high) of 2007 in Low & middle income?
Offer a very short reply. 0.01. What is the difference between the Rating (1=low 6=high) in 2005 and Rating (1=low 6=high) in 2008 in Low & middle income?
Make the answer very short. -0. What is the difference between the Rating (1=low 6=high) of 2006 and Rating (1=low 6=high) of 2007 in Low & middle income?
Ensure brevity in your answer.  -0.02. What is the difference between the Rating (1=low 6=high) of 2006 and Rating (1=low 6=high) of 2008 in Low & middle income?
Keep it short and to the point. -0.03. What is the difference between the Rating (1=low 6=high) in 2007 and Rating (1=low 6=high) in 2008 in Low & middle income?
Ensure brevity in your answer.  -0.01. What is the ratio of the Rating (1=low 6=high) in 2005 in Fragile and conflict affected situations to that in Heavily indebted poor countries?
Your answer should be compact. 0.89. What is the ratio of the Rating (1=low 6=high) of 2006 in Fragile and conflict affected situations to that in Heavily indebted poor countries?
Offer a terse response. 0.89. What is the ratio of the Rating (1=low 6=high) of 2007 in Fragile and conflict affected situations to that in Heavily indebted poor countries?
Give a very brief answer. 0.89. What is the ratio of the Rating (1=low 6=high) in 2008 in Fragile and conflict affected situations to that in Heavily indebted poor countries?
Your response must be concise. 0.88. What is the ratio of the Rating (1=low 6=high) in 2005 in Fragile and conflict affected situations to that in Latin America(all income levels)?
Your answer should be compact. 0.79. What is the ratio of the Rating (1=low 6=high) in 2006 in Fragile and conflict affected situations to that in Latin America(all income levels)?
Provide a short and direct response. 0.77. What is the ratio of the Rating (1=low 6=high) of 2007 in Fragile and conflict affected situations to that in Latin America(all income levels)?
Provide a short and direct response. 0.78. What is the ratio of the Rating (1=low 6=high) in 2008 in Fragile and conflict affected situations to that in Latin America(all income levels)?
Your response must be concise. 0.77. What is the ratio of the Rating (1=low 6=high) in 2005 in Fragile and conflict affected situations to that in Latin America(developing only)?
Provide a short and direct response. 0.79. What is the ratio of the Rating (1=low 6=high) in 2006 in Fragile and conflict affected situations to that in Latin America(developing only)?
Ensure brevity in your answer.  0.77. What is the ratio of the Rating (1=low 6=high) of 2007 in Fragile and conflict affected situations to that in Latin America(developing only)?
Provide a succinct answer. 0.78. What is the ratio of the Rating (1=low 6=high) in 2008 in Fragile and conflict affected situations to that in Latin America(developing only)?
Give a very brief answer. 0.77. What is the ratio of the Rating (1=low 6=high) of 2005 in Fragile and conflict affected situations to that in Least developed countries?
Ensure brevity in your answer.  0.9. What is the ratio of the Rating (1=low 6=high) in 2006 in Fragile and conflict affected situations to that in Least developed countries?
Keep it short and to the point. 0.89. What is the ratio of the Rating (1=low 6=high) of 2007 in Fragile and conflict affected situations to that in Least developed countries?
Provide a succinct answer. 0.89. What is the ratio of the Rating (1=low 6=high) in 2008 in Fragile and conflict affected situations to that in Least developed countries?
Ensure brevity in your answer.  0.89. What is the ratio of the Rating (1=low 6=high) of 2005 in Fragile and conflict affected situations to that in Low & middle income?
Your response must be concise. 0.86. What is the ratio of the Rating (1=low 6=high) in 2007 in Fragile and conflict affected situations to that in Low & middle income?
Give a very brief answer. 0.85. What is the ratio of the Rating (1=low 6=high) of 2008 in Fragile and conflict affected situations to that in Low & middle income?
Provide a succinct answer. 0.84. What is the ratio of the Rating (1=low 6=high) in 2005 in Heavily indebted poor countries to that in Latin America(all income levels)?
Keep it short and to the point. 0.89. What is the ratio of the Rating (1=low 6=high) of 2006 in Heavily indebted poor countries to that in Latin America(all income levels)?
Your response must be concise. 0.87. What is the ratio of the Rating (1=low 6=high) in 2007 in Heavily indebted poor countries to that in Latin America(all income levels)?
Provide a succinct answer. 0.88. What is the ratio of the Rating (1=low 6=high) of 2008 in Heavily indebted poor countries to that in Latin America(all income levels)?
Keep it short and to the point. 0.88. What is the ratio of the Rating (1=low 6=high) in 2005 in Heavily indebted poor countries to that in Latin America(developing only)?
Offer a very short reply. 0.89. What is the ratio of the Rating (1=low 6=high) of 2006 in Heavily indebted poor countries to that in Latin America(developing only)?
Your answer should be very brief. 0.87. What is the ratio of the Rating (1=low 6=high) in 2007 in Heavily indebted poor countries to that in Latin America(developing only)?
Your response must be concise. 0.88. What is the ratio of the Rating (1=low 6=high) in 2008 in Heavily indebted poor countries to that in Latin America(developing only)?
Keep it short and to the point. 0.88. What is the ratio of the Rating (1=low 6=high) in 2005 in Heavily indebted poor countries to that in Least developed countries?
Your answer should be compact. 1.01. What is the ratio of the Rating (1=low 6=high) in 2006 in Heavily indebted poor countries to that in Least developed countries?
Make the answer very short. 1.01. What is the ratio of the Rating (1=low 6=high) in 2008 in Heavily indebted poor countries to that in Least developed countries?
Your answer should be compact. 1.01. What is the ratio of the Rating (1=low 6=high) of 2005 in Heavily indebted poor countries to that in Low & middle income?
Offer a terse response. 0.96. What is the ratio of the Rating (1=low 6=high) in 2006 in Heavily indebted poor countries to that in Low & middle income?
Provide a short and direct response. 0.96. What is the ratio of the Rating (1=low 6=high) in 2007 in Heavily indebted poor countries to that in Low & middle income?
Offer a terse response. 0.96. What is the ratio of the Rating (1=low 6=high) in 2008 in Heavily indebted poor countries to that in Low & middle income?
Your answer should be very brief. 0.96. What is the ratio of the Rating (1=low 6=high) in 2005 in Latin America(all income levels) to that in Latin America(developing only)?
Ensure brevity in your answer.  1. What is the ratio of the Rating (1=low 6=high) of 2005 in Latin America(all income levels) to that in Least developed countries?
Offer a very short reply. 1.14. What is the ratio of the Rating (1=low 6=high) of 2006 in Latin America(all income levels) to that in Least developed countries?
Offer a very short reply. 1.16. What is the ratio of the Rating (1=low 6=high) of 2007 in Latin America(all income levels) to that in Least developed countries?
Ensure brevity in your answer.  1.14. What is the ratio of the Rating (1=low 6=high) in 2008 in Latin America(all income levels) to that in Least developed countries?
Provide a succinct answer. 1.16. What is the ratio of the Rating (1=low 6=high) of 2005 in Latin America(all income levels) to that in Low & middle income?
Make the answer very short. 1.09. What is the ratio of the Rating (1=low 6=high) in 2006 in Latin America(all income levels) to that in Low & middle income?
Offer a very short reply. 1.1. What is the ratio of the Rating (1=low 6=high) in 2007 in Latin America(all income levels) to that in Low & middle income?
Make the answer very short. 1.09. What is the ratio of the Rating (1=low 6=high) in 2008 in Latin America(all income levels) to that in Low & middle income?
Provide a succinct answer. 1.1. What is the ratio of the Rating (1=low 6=high) in 2005 in Latin America(developing only) to that in Least developed countries?
Your answer should be compact. 1.14. What is the ratio of the Rating (1=low 6=high) of 2006 in Latin America(developing only) to that in Least developed countries?
Offer a terse response. 1.16. What is the ratio of the Rating (1=low 6=high) of 2007 in Latin America(developing only) to that in Least developed countries?
Your answer should be very brief. 1.14. What is the ratio of the Rating (1=low 6=high) of 2008 in Latin America(developing only) to that in Least developed countries?
Give a very brief answer. 1.16. What is the ratio of the Rating (1=low 6=high) in 2005 in Latin America(developing only) to that in Low & middle income?
Keep it short and to the point. 1.09. What is the ratio of the Rating (1=low 6=high) in 2006 in Latin America(developing only) to that in Low & middle income?
Offer a very short reply. 1.1. What is the ratio of the Rating (1=low 6=high) of 2007 in Latin America(developing only) to that in Low & middle income?
Offer a terse response. 1.09. What is the ratio of the Rating (1=low 6=high) of 2008 in Latin America(developing only) to that in Low & middle income?
Provide a succinct answer. 1.1. What is the ratio of the Rating (1=low 6=high) of 2005 in Least developed countries to that in Low & middle income?
Keep it short and to the point. 0.95. What is the ratio of the Rating (1=low 6=high) in 2006 in Least developed countries to that in Low & middle income?
Make the answer very short. 0.95. What is the ratio of the Rating (1=low 6=high) of 2007 in Least developed countries to that in Low & middle income?
Your answer should be very brief. 0.95. What is the ratio of the Rating (1=low 6=high) of 2008 in Least developed countries to that in Low & middle income?
Provide a succinct answer. 0.95. What is the difference between the highest and the second highest Rating (1=low 6=high) in 2005?
Ensure brevity in your answer.  0. What is the difference between the highest and the second highest Rating (1=low 6=high) of 2006?
Your answer should be compact. 0. What is the difference between the highest and the lowest Rating (1=low 6=high) in 2005?
Offer a very short reply. 0.74. What is the difference between the highest and the lowest Rating (1=low 6=high) of 2006?
Keep it short and to the point. 0.81. What is the difference between the highest and the lowest Rating (1=low 6=high) of 2007?
Your answer should be compact. 0.77. What is the difference between the highest and the lowest Rating (1=low 6=high) in 2008?
Provide a succinct answer. 0.84. 